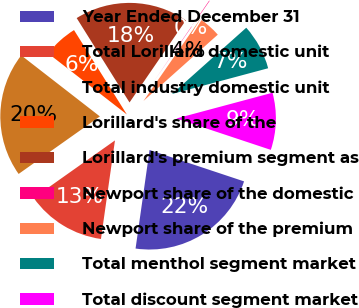Convert chart to OTSL. <chart><loc_0><loc_0><loc_500><loc_500><pie_chart><fcel>Year Ended December 31<fcel>Total Lorillard domestic unit<fcel>Total industry domestic unit<fcel>Lorillard's share of the<fcel>Lorillard's premium segment as<fcel>Newport share of the domestic<fcel>Newport share of the premium<fcel>Total menthol segment market<fcel>Total discount segment market<nl><fcel>22.14%<fcel>12.95%<fcel>20.31%<fcel>5.59%<fcel>18.47%<fcel>0.08%<fcel>3.76%<fcel>7.43%<fcel>9.27%<nl></chart> 